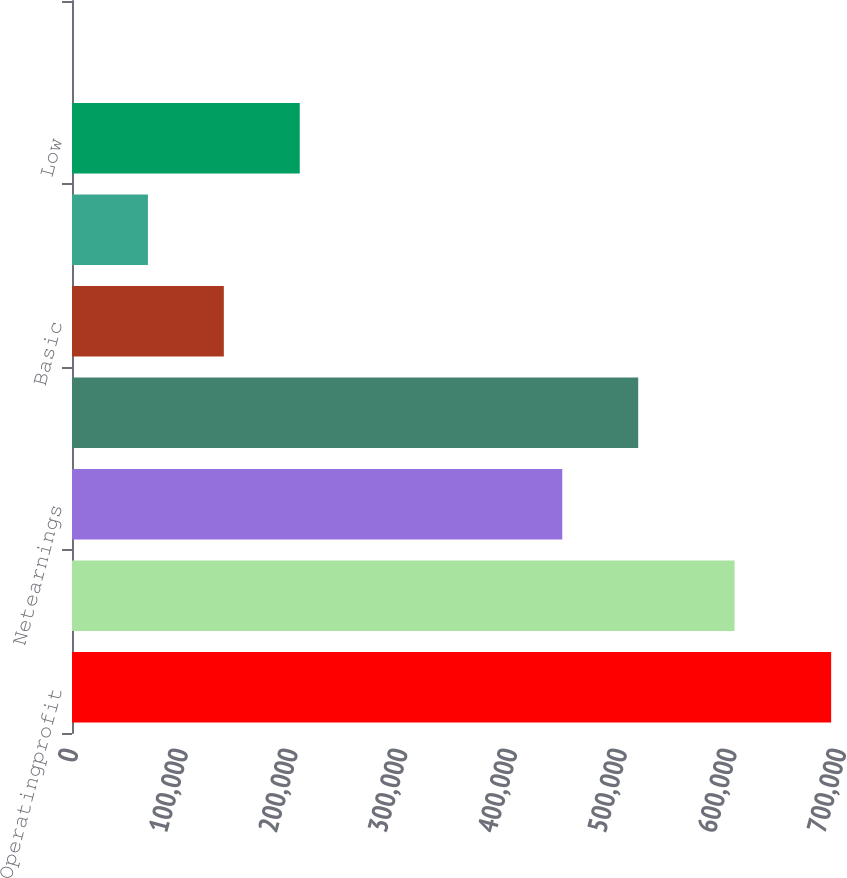<chart> <loc_0><loc_0><loc_500><loc_500><bar_chart><fcel>Operatingprofit<fcel>Earningsbeforeincometaxes<fcel>Netearnings<fcel>Unnamed: 3<fcel>Basic<fcel>Diluted<fcel>Low<fcel>Cashdividendsdeclared<nl><fcel>691933<fcel>603915<fcel>446872<fcel>516065<fcel>138388<fcel>69195<fcel>207581<fcel>1.84<nl></chart> 